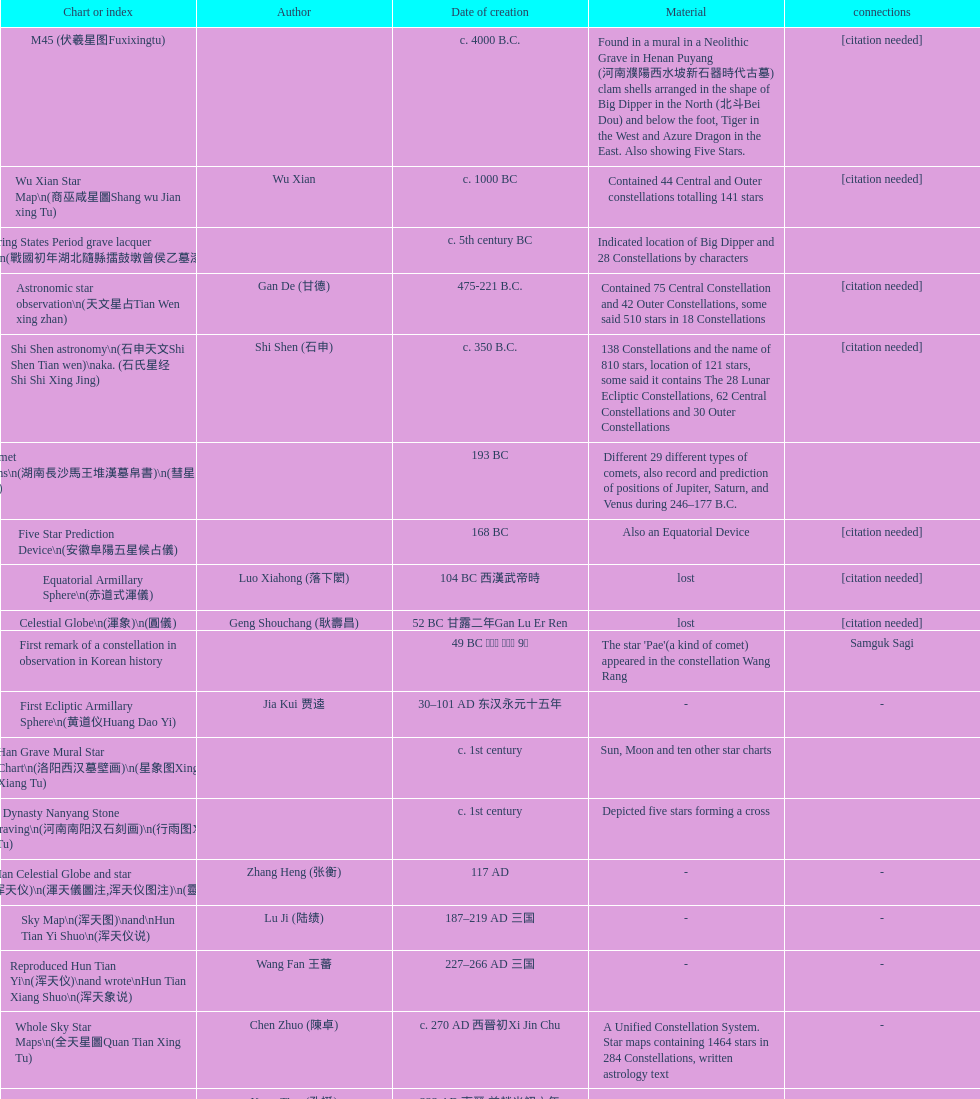Which star map was created earlier, celestial globe or the han grave mural star chart? Celestial Globe. Could you parse the entire table as a dict? {'header': ['Chart or index', 'Author', 'Date of creation', 'Material', 'connections'], 'rows': [['M45 (伏羲星图Fuxixingtu)', '', 'c. 4000 B.C.', 'Found in a mural in a Neolithic Grave in Henan Puyang (河南濮陽西水坡新石器時代古墓) clam shells arranged in the shape of Big Dipper in the North (北斗Bei Dou) and below the foot, Tiger in the West and Azure Dragon in the East. Also showing Five Stars.', '[citation needed]'], ['Wu Xian Star Map\\n(商巫咸星圖Shang wu Jian xing Tu)', 'Wu Xian', 'c. 1000 BC', 'Contained 44 Central and Outer constellations totalling 141 stars', '[citation needed]'], ['Warring States Period grave lacquer box\\n(戰國初年湖北隨縣擂鼓墩曾侯乙墓漆箱)', '', 'c. 5th century BC', 'Indicated location of Big Dipper and 28 Constellations by characters', ''], ['Astronomic star observation\\n(天文星占Tian Wen xing zhan)', 'Gan De (甘德)', '475-221 B.C.', 'Contained 75 Central Constellation and 42 Outer Constellations, some said 510 stars in 18 Constellations', '[citation needed]'], ['Shi Shen astronomy\\n(石申天文Shi Shen Tian wen)\\naka. (石氏星经 Shi Shi Xing Jing)', 'Shi Shen (石申)', 'c. 350 B.C.', '138 Constellations and the name of 810 stars, location of 121 stars, some said it contains The 28 Lunar Ecliptic Constellations, 62 Central Constellations and 30 Outer Constellations', '[citation needed]'], ['Han Comet Diagrams\\n(湖南長沙馬王堆漢墓帛書)\\n(彗星圖Meng xing Tu)', '', '193 BC', 'Different 29 different types of comets, also record and prediction of positions of Jupiter, Saturn, and Venus during 246–177 B.C.', ''], ['Five Star Prediction Device\\n(安徽阜陽五星候占儀)', '', '168 BC', 'Also an Equatorial Device', '[citation needed]'], ['Equatorial Armillary Sphere\\n(赤道式渾儀)', 'Luo Xiahong (落下閎)', '104 BC 西漢武帝時', 'lost', '[citation needed]'], ['Celestial Globe\\n(渾象)\\n(圓儀)', 'Geng Shouchang (耿壽昌)', '52 BC 甘露二年Gan Lu Er Ren', 'lost', '[citation needed]'], ['First remark of a constellation in observation in Korean history', '', '49 BC 혁거세 거서간 9년', "The star 'Pae'(a kind of comet) appeared in the constellation Wang Rang", 'Samguk Sagi'], ['First Ecliptic Armillary Sphere\\n(黄道仪Huang Dao Yi)', 'Jia Kui 贾逵', '30–101 AD 东汉永元十五年', '-', '-'], ['Han Grave Mural Star Chart\\n(洛阳西汉墓壁画)\\n(星象图Xing Xiang Tu)', '', 'c. 1st century', 'Sun, Moon and ten other star charts', ''], ['Han Dynasty Nanyang Stone Engraving\\n(河南南阳汉石刻画)\\n(行雨图Xing Yu Tu)', '', 'c. 1st century', 'Depicted five stars forming a cross', ''], ['Eastern Han Celestial Globe and star maps\\n(浑天仪)\\n(渾天儀圖注,浑天仪图注)\\n(靈憲,灵宪)', 'Zhang Heng (张衡)', '117 AD', '-', '-'], ['Sky Map\\n(浑天图)\\nand\\nHun Tian Yi Shuo\\n(浑天仪说)', 'Lu Ji (陆绩)', '187–219 AD 三国', '-', '-'], ['Reproduced Hun Tian Yi\\n(浑天仪)\\nand wrote\\nHun Tian Xiang Shuo\\n(浑天象说)', 'Wang Fan 王蕃', '227–266 AD 三国', '-', '-'], ['Whole Sky Star Maps\\n(全天星圖Quan Tian Xing Tu)', 'Chen Zhuo (陳卓)', 'c. 270 AD 西晉初Xi Jin Chu', 'A Unified Constellation System. Star maps containing 1464 stars in 284 Constellations, written astrology text', '-'], ['Equatorial Armillary Sphere\\n(渾儀Hun Xi)', 'Kong Ting (孔挺)', '323 AD 東晉 前趙光初六年', 'level being used in this kind of device', '-'], ['Northern Wei Period Iron Armillary Sphere\\n(鐵渾儀)', 'Hu Lan (斛蘭)', 'Bei Wei\\plevel being used in this kind of device', '-', ''], ['Southern Dynasties Period Whole Sky Planetarium\\n(渾天象Hun Tian Xiang)', 'Qian Lezhi (錢樂之)', '443 AD 南朝劉宋元嘉年間', 'used red, black and white to differentiate stars from different star maps from Shi Shen, Gan De and Wu Xian 甘, 石, 巫三家星', '-'], ['Northern Wei Grave Dome Star Map\\n(河南洛陽北魏墓頂星圖)', '', '526 AD 北魏孝昌二年', 'about 300 stars, including the Big Dipper, some stars are linked by straight lines to form constellation. The Milky Way is also shown.', ''], ['Water-powered Planetarium\\n(水力渾天儀)', 'Geng Xun (耿詢)', 'c. 7th century 隋初Sui Chu', '-', '-'], ['Lingtai Miyuan\\n(靈台秘苑)', 'Yu Jicai (庾季才) and Zhou Fen (周墳)', '604 AD 隋Sui', 'incorporated star maps from different sources', '-'], ['Tang Dynasty Whole Sky Ecliptic Armillary Sphere\\n(渾天黃道儀)', 'Li Chunfeng 李淳風', '667 AD 貞觀七年', 'including Elliptic and Moon orbit, in addition to old equatorial design', '-'], ['The Dunhuang star map\\n(燉煌)', 'Dun Huang', '705–710 AD', '1,585 stars grouped into 257 clusters or "asterisms"', ''], ['Turfan Tomb Star Mural\\n(新疆吐鲁番阿斯塔那天文壁画)', '', '250–799 AD 唐', '28 Constellations, Milkyway and Five Stars', ''], ['Picture of Fuxi and Nüwa 新疆阿斯達那唐墓伏羲Fu Xi 女媧NV Wa像Xiang', '', 'Tang Dynasty', 'Picture of Fuxi and Nuwa together with some constellations', 'Image:Nuva fuxi.gif'], ['Tang Dynasty Armillary Sphere\\n(唐代渾儀Tang Dai Hun Xi)\\n(黃道遊儀Huang dao you xi)', 'Yixing Monk 一行和尚 (张遂)Zhang Sui and Liang Lingzan 梁令瓚', '683–727 AD', 'based on Han Dynasty Celestial Globe, recalibrated locations of 150 stars, determined that stars are moving', ''], ['Tang Dynasty Indian Horoscope Chart\\n(梵天火羅九曜)', 'Yixing Priest 一行和尚 (张遂)\\pZhang Sui\\p683–727 AD', 'simple diagrams of the 28 Constellation', '', ''], ['Kitora Kofun 法隆寺FaLong Si\u3000キトラ古墳 in Japan', '', 'c. late 7th century – early 8th century', 'Detailed whole sky map', ''], ['Treatise on Astrology of the Kaiyuan Era\\n(開元占経,开元占经Kai Yuan zhang Jing)', 'Gautama Siddha', '713 AD –', 'Collection of the three old star charts from Shi Shen, Gan De and Wu Xian. One of the most renowned collection recognized academically.', '-'], ['Big Dipper\\n(山東嘉祥武梁寺石刻北斗星)', '', '–', 'showing stars in Big Dipper', ''], ['Prajvalonisa Vjrabhairava Padvinasa-sri-dharani Scroll found in Japan 熾盛光佛頂大威德銷災吉祥陀羅尼經卷首扉畫', '', '972 AD 北宋開寶五年', 'Chinese 28 Constellations and Western Zodiac', '-'], ['Tangut Khara-Khoto (The Black City) Star Map 西夏黑水城星圖', '', '940 AD', 'A typical Qian Lezhi Style Star Map', '-'], ['Star Chart 五代吳越文穆王前元瓘墓石刻星象圖', '', '941–960 AD', '-', ''], ['Ancient Star Map 先天图 by 陈抟Chen Tuan', '', 'c. 11th Chen Tuan 宋Song', 'Perhaps based on studying of Puyong Ancient Star Map', 'Lost'], ['Song Dynasty Bronze Armillary Sphere 北宋至道銅渾儀', 'Han Xianfu 韓顯符', '1006 AD 宋道元年十二月', 'Similar to the Simplified Armillary by Kong Ting 孔挺, 晁崇 Chao Chong, 斛蘭 Hu Lan', '-'], ['Song Dynasty Bronze Armillary Sphere 北宋天文院黄道渾儀', 'Shu Yijian 舒易簡, Yu Yuan 于渊, Zhou Cong 周琮', '宋皇祐年中', 'Similar to the Armillary by Tang Dynasty Liang Lingzan 梁令瓚 and Yi Xing 一行', '-'], ['Song Dynasty Armillary Sphere 北宋簡化渾儀', 'Shen Kuo 沈括 and Huangfu Yu 皇甫愈', '1089 AD 熙寧七年', 'Simplied version of Tang Dynasty Device, removed the rarely used moon orbit.', '-'], ['Five Star Charts (新儀象法要)', 'Su Song 蘇頌', '1094 AD', '1464 stars grouped into 283 asterisms', 'Image:Su Song Star Map 1.JPG\\nImage:Su Song Star Map 2.JPG'], ['Song Dynasty Water-powered Planetarium 宋代 水运仪象台', 'Su Song 蘇頌 and Han Gonglian 韩公廉', 'c. 11th century', '-', ''], ['Liao Dynasty Tomb Dome Star Map 遼宣化张世卿墓頂星圖', '', '1116 AD 遼天庆六年', 'shown both the Chinese 28 Constellation encircled by Babylonian Zodiac', ''], ["Star Map in a woman's grave (江西德安 南宋周氏墓星相图)", '', '1127–1279 AD', 'Milky Way and 57 other stars.', ''], ['Hun Tian Yi Tong Xing Xiang Quan Tu, Suzhou Star Chart (蘇州石刻天文圖),淳祐天文図', 'Huang Shang (黃裳)', 'created in 1193, etched to stone in 1247 by Wang Zhi Yuan 王致遠', '1434 Stars grouped into 280 Asterisms in Northern Sky map', ''], ['Yuan Dynasty Simplified Armillary Sphere 元代簡儀', 'Guo Shou Jing 郭守敬', '1276–1279', 'Further simplied version of Song Dynasty Device', ''], ['Japanese Star Chart 格子月進図', '', '1324', 'Similar to Su Song Star Chart, original burned in air raids during World War II, only pictures left. Reprinted in 1984 by 佐佐木英治', ''], ['天象列次分野之図(Cheonsang Yeolcha Bunyajido)', '', '1395', 'Korean versions of Star Map in Stone. It was made in Chosun Dynasty and the constellation names were written in Chinese letter. The constellations as this was found in Japanese later. Contained 1,464 stars.', ''], ['Japanese Star Chart 瀧谷寺 天之図', '', 'c. 14th or 15th centuries 室町中期以前', '-', ''], ["Korean King Sejong's Armillary sphere", '', '1433', '-', ''], ['Star Chart', 'Mao Kun 茅坤', 'c. 1422', 'Polaris compared with Southern Cross and Alpha Centauri', 'zh:郑和航海图'], ['Korean Tomb', '', 'c. late 14th century', 'Big Dipper', ''], ['Ming Ancient Star Chart 北京隆福寺(古星圖)', '', 'c. 1453 明代', '1420 Stars, possibly based on old star maps from Tang Dynasty', ''], ['Chanshu Star Chart (明常熟石刻天文圖)', '', '1506', 'Based on Suzhou Star Chart, Northern Sky observed at 36.8 degrees North Latitude, 1466 stars grouped into 284 asterism', '-'], ['Ming Dynasty Star Map (渾蓋通憲圖說)', 'Matteo Ricci 利玛窦Li Ma Dou, recorded by Li Zhizao 李之藻', 'c. 1550', '-', ''], ['Tian Wun Tu (天问图)', 'Xiao Yun Cong 萧云从', 'c. 1600', 'Contained mapping of 12 constellations and 12 animals', ''], ['Zhou Tian Xuan Ji Tu (周天璇玑图) and He He Si Xiang Tu (和合四象圖) in Xing Ming Gui Zhi (性命圭旨)', 'by 尹真人高第弟子 published by 余永宁', '1615', 'Drawings of Armillary Sphere and four Chinese Celestial Animals with some notes. Related to Taoism.', ''], ['Korean Astronomy Book "Selected and Systematized Astronomy Notes" 天文類抄', '', '1623~1649', 'Contained some star maps', ''], ['Ming Dynasty General Star Map (赤道南北兩總星圖)', 'Xu Guang ci 徐光啟 and Adam Schall von Bell Tang Ruo Wang湯若望', '1634', '-', ''], ['Ming Dynasty diagrams of Armillary spheres and Celestial Globes', 'Xu Guang ci 徐光啟', 'c. 1699', '-', ''], ['Ming Dynasty Planetarium Machine (渾象 Hui Xiang)', '', 'c. 17th century', 'Ecliptic, Equator, and dividers of 28 constellation', ''], ['Copper Plate Star Map stored in Korea', '', '1652 順治九年shun zi jiu nian', '-', ''], ['Japanese Edo period Star Chart 天象列次之図 based on 天象列次分野之図 from Korean', 'Harumi Shibukawa 渋川春海Bu Chuan Chun Mei(保井春海Bao Jing Chun Mei)', '1670 寛文十年', '-', ''], ['The Celestial Globe 清康熙 天體儀', 'Ferdinand Verbiest 南懷仁', '1673', '1876 stars grouped into 282 asterisms', ''], ['Picture depicted Song Dynasty fictional astronomer (呉用 Wu Yong) with a Celestial Globe (天體儀)', 'Japanese painter', '1675', 'showing top portion of a Celestial Globe', 'File:Chinese astronomer 1675.jpg'], ['Japanese Edo period Star Chart 天文分野之図', 'Harumi Shibukawa 渋川春海BuJingChun Mei (保井春海Bao JingChunMei)', '1677 延宝五年', '-', ''], ['Korean star map in stone', '', '1687', '-', ''], ['Japanese Edo period Star Chart 天文図解', '井口常範', '1689 元禄2年', '-', '-'], ['Japanese Edo period Star Chart 古暦便覧備考', '苗村丈伯Mao Chun Zhang Bo', '1692 元禄5年', '-', '-'], ['Japanese star chart', 'Harumi Yasui written in Chinese', '1699 AD', 'A Japanese star chart of 1699 showing lunar stations', ''], ['Japanese Edo period Star Chart 天文成象Tian Wen Cheng xiang', '(渋川昔尹She Chuan Xi Yin) (保井昔尹Bao Jing Xi Yin)', '1699 元禄十二年', 'including Stars from Wu Shien (44 Constellation, 144 stars) in yellow; Gan De (118 Constellations, 511 stars) in black; Shi Shen (138 Constellations, 810 stars) in red and Harumi Shibukawa (61 Constellations, 308 stars) in blue;', ''], ['Japanese Star Chart 改正天文図説', '', 'unknown', 'Included stars from Harumi Shibukawa', ''], ['Korean Star Map Stone', '', 'c. 17th century', '-', ''], ['Korean Star Map', '', 'c. 17th century', '-', ''], ['Ceramic Ink Sink Cover', '', 'c. 17th century', 'Showing Big Dipper', ''], ['Korean Star Map Cube 方星圖', 'Italian Missionary Philippus Maria Grimardi 閔明我 (1639~1712)', 'c. early 18th century', '-', ''], ['Star Chart preserved in Japan based on a book from China 天経或問', 'You Zi liu 游子六', '1730 AD 江戸時代 享保15年', 'A Northern Sky Chart in Chinese', ''], ['Star Chart 清蒙文石刻(欽天監繪製天文圖) in Mongolia', '', '1727–1732 AD', '1550 stars grouped into 270 starisms.', ''], ['Korean Star Maps, North and South to the Eclliptic 黃道南北恒星圖', '', '1742', '-', ''], ['Japanese Edo period Star Chart 天経或問註解図巻\u3000下', '入江脩敬Ru Jiang YOu Jing', '1750 寛延3年', '-', '-'], ['Reproduction of an ancient device 璇璣玉衡', 'Dai Zhen 戴震', '1723–1777 AD', 'based on ancient record and his own interpretation', 'Could be similar to'], ['Rock Star Chart 清代天文石', '', 'c. 18th century', 'A Star Chart and general Astronomy Text', ''], ['Korean Complete Star Map (渾天全圖)', '', 'c. 18th century', '-', ''], ['Qing Dynasty Star Catalog (儀象考成,仪象考成)恒星表 and Star Map 黄道南北両星総図', 'Yun Lu 允禄 and Ignatius Kogler 戴进贤Dai Jin Xian 戴進賢, a German', 'Device made in 1744, book completed in 1757 清乾隆年间', '300 Constellations and 3083 Stars. Referenced Star Catalogue published by John Flamsteed', ''], ['Jingban Tianwen Quantu by Ma Junliang 马俊良', '', '1780–90 AD', 'mapping nations to the sky', ''], ['Japanese Edo period Illustration of a Star Measuring Device 平天儀図解', 'Yan Qiao Shan Bing Heng 岩橋善兵衛', '1802 Xiang He Er Nian 享和二年', '-', 'The device could be similar to'], ['North Sky Map 清嘉庆年间Huang Dao Zhong Xi He Tu(黄道中西合图)', 'Xu Choujun 徐朝俊', '1807 AD', 'More than 1000 stars and the 28 consellation', ''], ['Japanese Edo period Star Chart 天象総星之図', 'Chao Ye Bei Shui 朝野北水', '1814 文化十一年', '-', '-'], ['Japanese Edo period Star Chart 新制天球星象記', '田中政均', '1815 文化十二年', '-', '-'], ['Japanese Edo period Star Chart 天球図', '坂部廣胖', '1816 文化十三年', '-', '-'], ['Chinese Star map', 'John Reeves esq', '1819 AD', 'Printed map showing Chinese names of stars and constellations', ''], ['Japanese Edo period Star Chart 昊天図説詳解', '佐藤祐之', '1824 文政七年', '-', '-'], ['Japanese Edo period Star Chart 星図歩天歌', '小島好謙 and 鈴木世孝', '1824 文政七年', '-', '-'], ['Japanese Edo period Star Chart', '鈴木世孝', '1824 文政七年', '-', '-'], ['Japanese Edo period Star Chart 天象管鈔 天体図 (天文星象図解)', '長久保赤水', '1824 文政七年', '-', ''], ['Japanese Edo period Star Measuring Device 中星儀', '足立信順Zhu Li Xin Shun', '1824 文政七年', '-', '-'], ['Japanese Star Map 天象一覧図 in Kanji', '桜田虎門', '1824 AD 文政７年', 'Printed map showing Chinese names of stars and constellations', ''], ['Korean Star Map 天象列次分野之図 in Kanji', '', 'c. 19th century', 'Printed map showing Chinese names of stars and constellations', '[18]'], ['Korean Star Map', '', 'c. 19th century, late Choson Period', '-', ''], ['Korean Star maps: Star Map South to the Ecliptic 黃道南恒星圖 and Star Map South to the Ecliptic 黃道北恒星圖', '', 'c. 19th century', 'Perhaps influenced by Adam Schall von Bell Tang Ruo wang 湯若望 (1591–1666) and P. Ignatius Koegler 戴進賢 (1680–1748)', ''], ['Korean Complete map of the celestial sphere (渾天全圖)', '', 'c. 19th century', '-', ''], ['Korean Book of Stars 經星', '', 'c. 19th century', 'Several star maps', ''], ['Japanese Edo period Star Chart 方円星図,方圓星図 and 増補分度星図方図', '石坂常堅', '1826b文政9年', '-', '-'], ['Japanese Star Chart', '伊能忠誨', 'c. 19th century', '-', '-'], ['Japanese Edo period Star Chart 天球図説', '古筆源了材', '1835 天保6年', '-', '-'], ['Qing Dynasty Star Catalog (儀象考成續編)星表', '', '1844', 'Appendix to Yi Xian Kao Cheng, listed 3240 stars (added 163, removed 6)', ''], ['Stars map (恒星赤道経緯度図)stored in Japan', '', '1844 道光24年 or 1848', '-', '-'], ['Japanese Edo period Star Chart 経緯簡儀用法', '藤岡有貞', '1845 弘化２年', '-', '-'], ['Japanese Edo period Star Chart 分野星図', '高塚福昌, 阿部比輔, 上条景弘', '1849 嘉永2年', '-', '-'], ['Japanese Late Edo period Star Chart 天文図屏風', '遠藤盛俊', 'late Edo Period 江戸時代後期', '-', '-'], ['Japanese Star Chart 天体図', '三浦梅園', '-', '-', '-'], ['Japanese Star Chart 梅園星図', '高橋景保', '-', '-', ''], ['Korean Book of New Song of the Sky Pacer 新法步天歌', '李俊養', '1862', 'Star maps and a revised version of the Song of Sky Pacer', ''], ['Stars South of Equator, Stars North of Equator (赤道南恆星圖,赤道北恆星圖)', '', '1875～1908 清末光緒年間', 'Similar to Ming Dynasty General Star Map', ''], ['Fuxi 64 gua 28 xu wood carving 天水市卦台山伏羲六十四卦二十八宿全图', '', 'modern', '-', '-'], ['Korean Map of Heaven and Earth 天地圖', '', 'c. 19th century', '28 Constellations and geographic map', ''], ['Korean version of 28 Constellation 列宿圖', '', 'c. 19th century', '28 Constellations, some named differently from their Chinese counterparts', ''], ['Korean Star Chart 渾天図', '朴?', '-', '-', '-'], ['Star Chart in a Dao Temple 玉皇山道觀星圖', '', '1940 AD', '-', '-'], ['Simplified Chinese and Western Star Map', 'Yi Shi Tong 伊世同', 'Aug. 1963', 'Star Map showing Chinese Xingquan and Western Constellation boundaries', ''], ['Sky Map', 'Yu Xi Dao Ren 玉溪道人', '1987', 'Star Map with captions', ''], ['The Chinese Sky during the Han Constellating Stars and Society', 'Sun Xiaochun and Jacob Kistemaker', '1997 AD', 'An attempt to recreate night sky seen by Chinese 2000 years ago', ''], ['Star map', '', 'Recent', 'An attempt by a Japanese to reconstruct the night sky for a historical event around 235 AD 秋風五丈原', ''], ['Star maps', '', 'Recent', 'Chinese 28 Constellation with Chinese and Japanese captions', ''], ['SinoSky Beta 2.0', '', '2002', 'A computer program capable of showing Chinese Xingguans alongside with western constellations, lists about 700 stars with Chinese names.', ''], ['AEEA Star maps', '', 'Modern', 'Good reconstruction and explanation of Chinese constellations', ''], ['Wikipedia Star maps', '', 'Modern', '-', 'zh:華蓋星'], ['28 Constellations, big dipper and 4 symbols Star map', '', 'Modern', '-', ''], ['Collection of printed star maps', '', 'Modern', '-', ''], ['28 Xu Star map and catalog', '-', 'Modern', 'Stars around ecliptic', ''], ['HNSKY Korean/Chinese Supplement', 'Jeong, Tae-Min(jtm71)/Chuang_Siau_Chin', 'Modern', 'Korean supplement is based on CheonSangYeulChaBunYaZiDo (B.C.100 ~ A.D.100)', ''], ['Stellarium Chinese and Korean Sky Culture', 'G.S.K. Lee; Jeong, Tae-Min(jtm71); Yu-Pu Wang (evanzxcv)', 'Modern', 'Major Xingguans and Star names', ''], ['修真內外火侯全圖 Huo Hou Tu', 'Xi Chun Sheng Chong Hui\\p2005 redrawn, original unknown', 'illustrations of Milkyway and star maps, Chinese constellations in Taoism view', '', ''], ['Star Map with illustrations for Xingguans', '坐井★观星Zuo Jing Guan Xing', 'Modern', 'illustrations for cylindrical and circular polar maps', ''], ['Sky in Google Earth KML', '', 'Modern', 'Attempts to show Chinese Star Maps on Google Earth', '']]} 